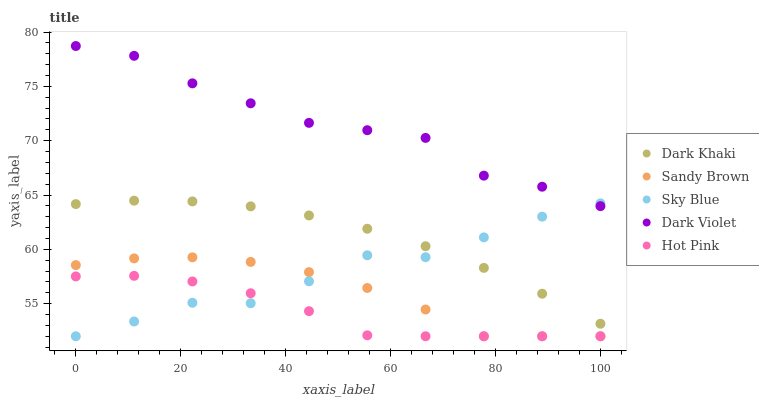Does Hot Pink have the minimum area under the curve?
Answer yes or no. Yes. Does Dark Violet have the maximum area under the curve?
Answer yes or no. Yes. Does Sky Blue have the minimum area under the curve?
Answer yes or no. No. Does Sky Blue have the maximum area under the curve?
Answer yes or no. No. Is Dark Khaki the smoothest?
Answer yes or no. Yes. Is Sky Blue the roughest?
Answer yes or no. Yes. Is Hot Pink the smoothest?
Answer yes or no. No. Is Hot Pink the roughest?
Answer yes or no. No. Does Sky Blue have the lowest value?
Answer yes or no. Yes. Does Dark Violet have the lowest value?
Answer yes or no. No. Does Dark Violet have the highest value?
Answer yes or no. Yes. Does Sky Blue have the highest value?
Answer yes or no. No. Is Hot Pink less than Dark Violet?
Answer yes or no. Yes. Is Dark Violet greater than Hot Pink?
Answer yes or no. Yes. Does Dark Khaki intersect Sky Blue?
Answer yes or no. Yes. Is Dark Khaki less than Sky Blue?
Answer yes or no. No. Is Dark Khaki greater than Sky Blue?
Answer yes or no. No. Does Hot Pink intersect Dark Violet?
Answer yes or no. No. 